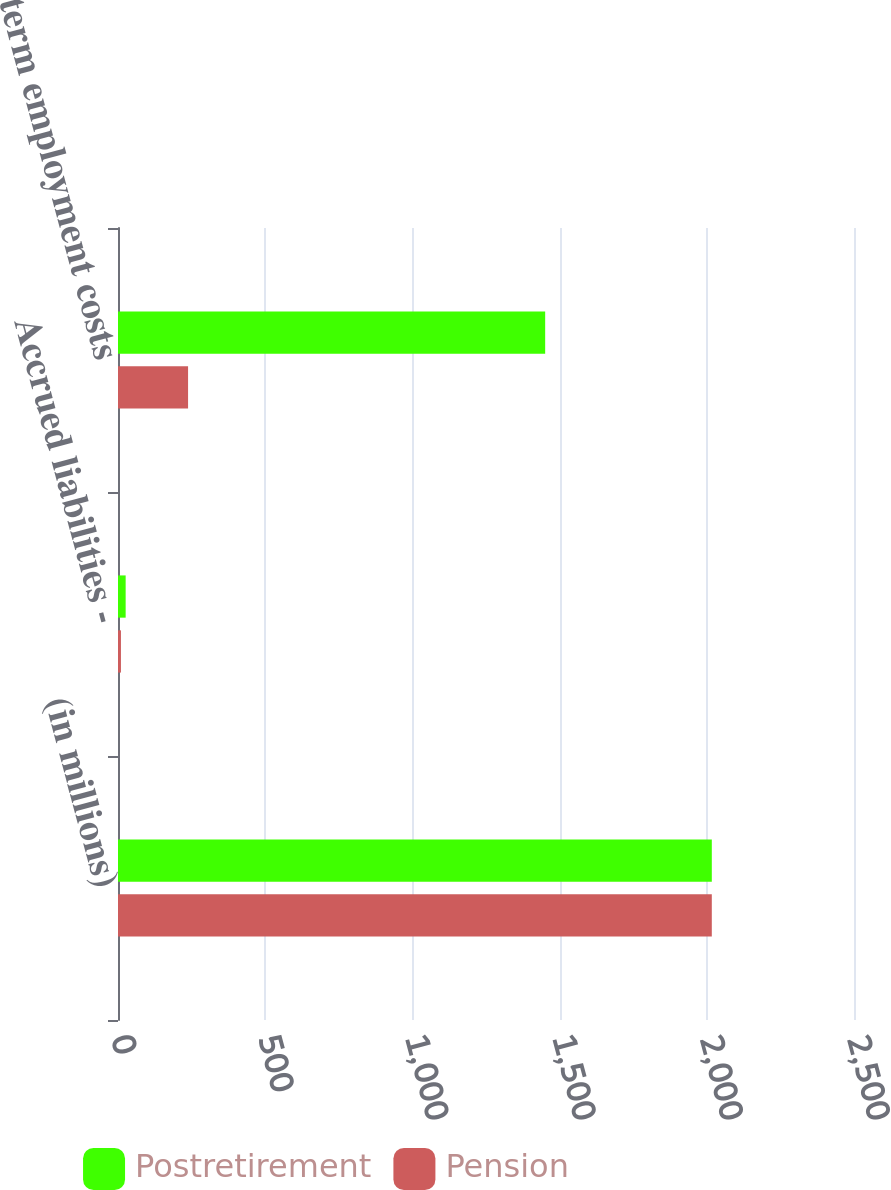<chart> <loc_0><loc_0><loc_500><loc_500><stacked_bar_chart><ecel><fcel>(in millions)<fcel>Accrued liabilities -<fcel>Long-term employment costs<nl><fcel>Postretirement<fcel>2017<fcel>26<fcel>1451<nl><fcel>Pension<fcel>2017<fcel>10<fcel>238<nl></chart> 